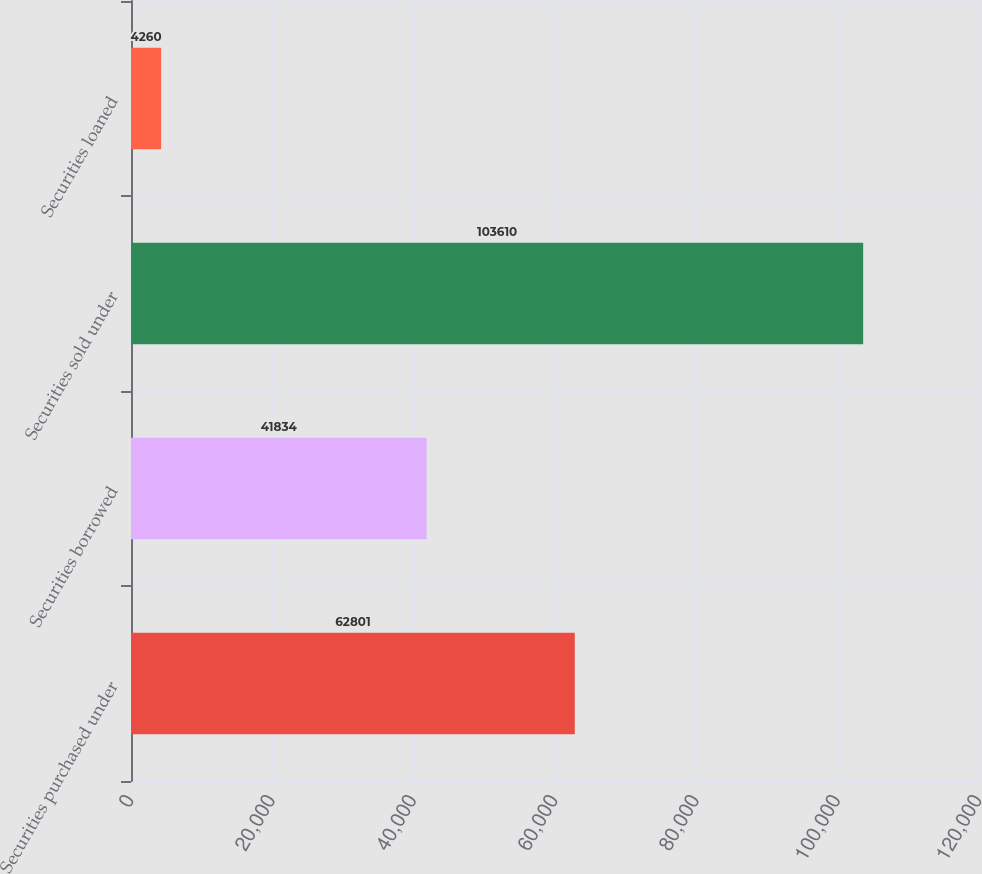Convert chart. <chart><loc_0><loc_0><loc_500><loc_500><bar_chart><fcel>Securities purchased under<fcel>Securities borrowed<fcel>Securities sold under<fcel>Securities loaned<nl><fcel>62801<fcel>41834<fcel>103610<fcel>4260<nl></chart> 